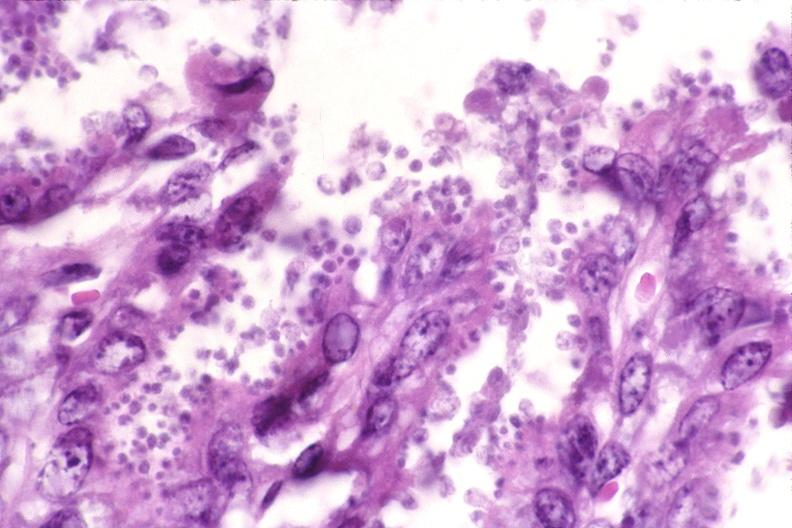what does this image show?
Answer the question using a single word or phrase. Colon 